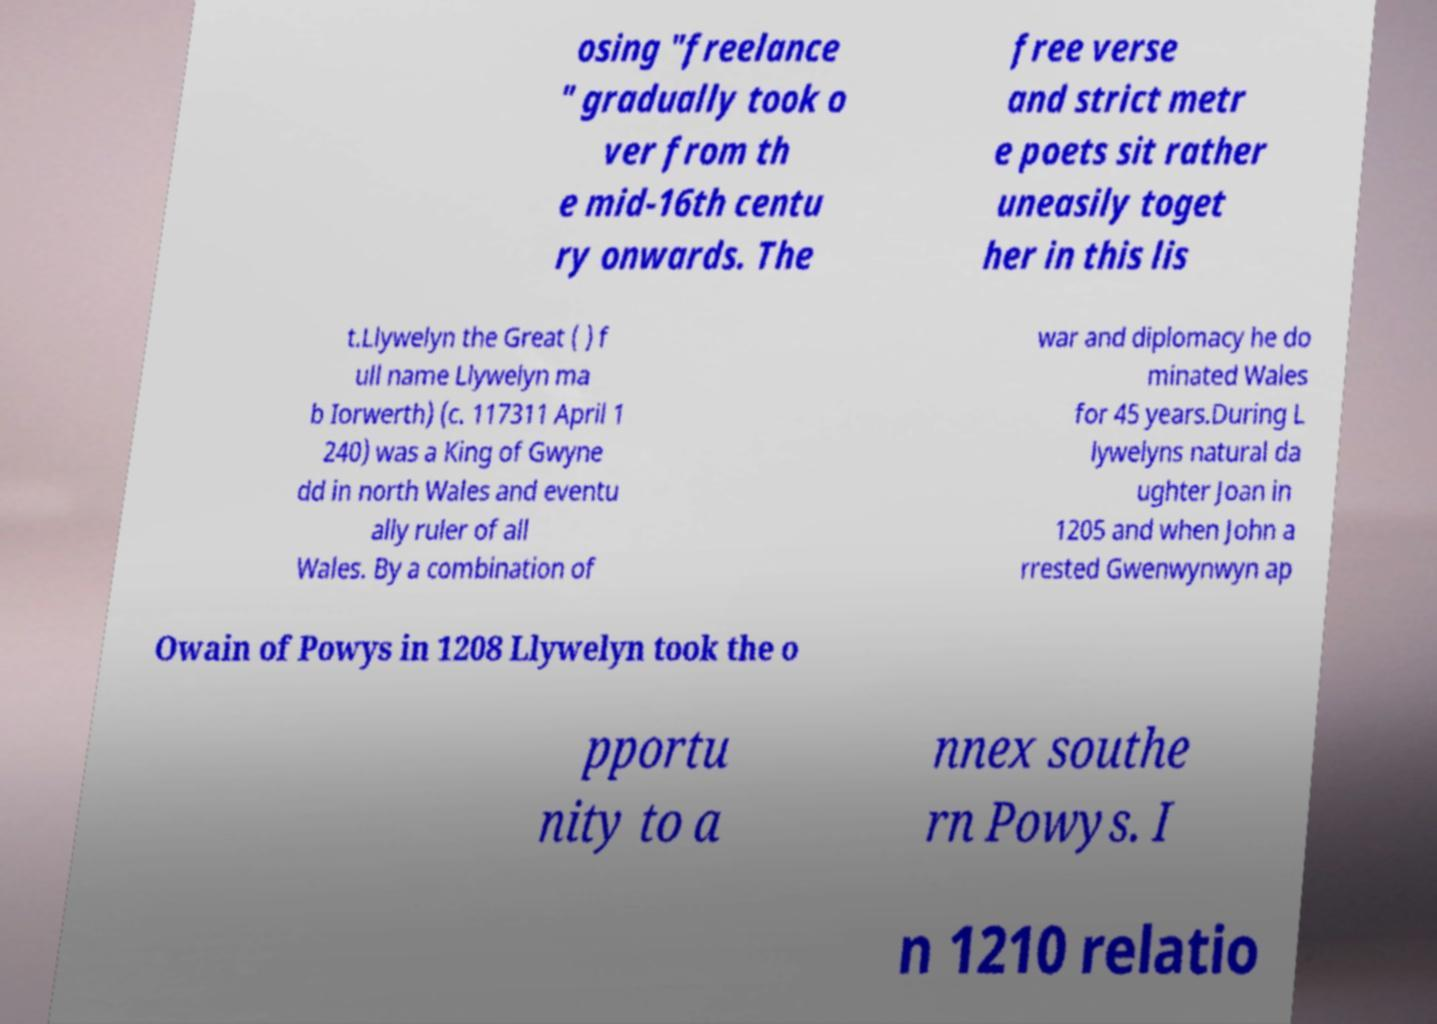What messages or text are displayed in this image? I need them in a readable, typed format. osing "freelance " gradually took o ver from th e mid-16th centu ry onwards. The free verse and strict metr e poets sit rather uneasily toget her in this lis t.Llywelyn the Great ( ) f ull name Llywelyn ma b Iorwerth) (c. 117311 April 1 240) was a King of Gwyne dd in north Wales and eventu ally ruler of all Wales. By a combination of war and diplomacy he do minated Wales for 45 years.During L lywelyns natural da ughter Joan in 1205 and when John a rrested Gwenwynwyn ap Owain of Powys in 1208 Llywelyn took the o pportu nity to a nnex southe rn Powys. I n 1210 relatio 